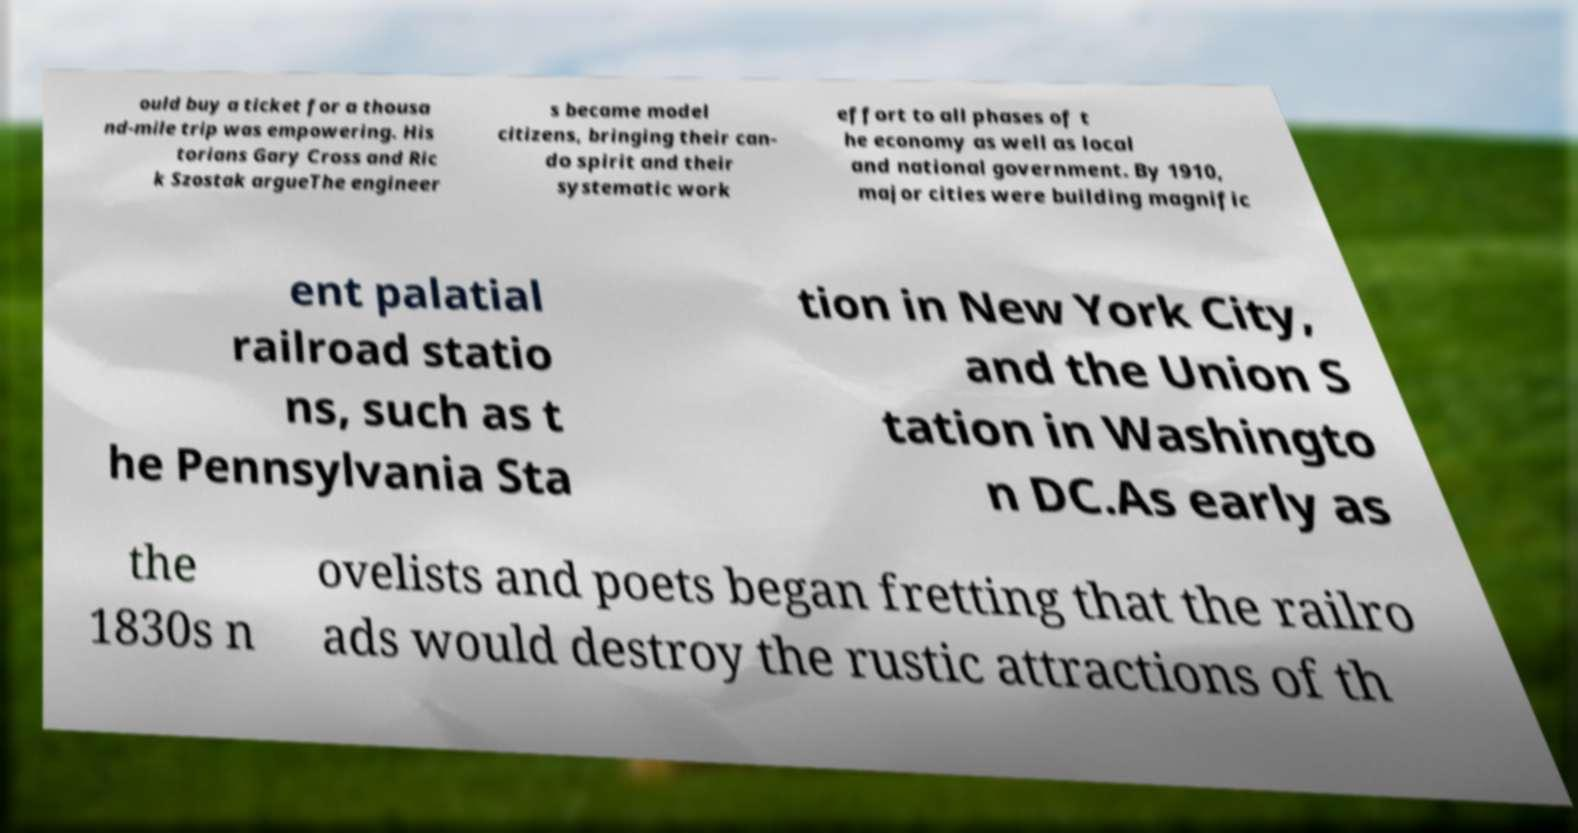Could you extract and type out the text from this image? ould buy a ticket for a thousa nd-mile trip was empowering. His torians Gary Cross and Ric k Szostak argueThe engineer s became model citizens, bringing their can- do spirit and their systematic work effort to all phases of t he economy as well as local and national government. By 1910, major cities were building magnific ent palatial railroad statio ns, such as t he Pennsylvania Sta tion in New York City, and the Union S tation in Washingto n DC.As early as the 1830s n ovelists and poets began fretting that the railro ads would destroy the rustic attractions of th 